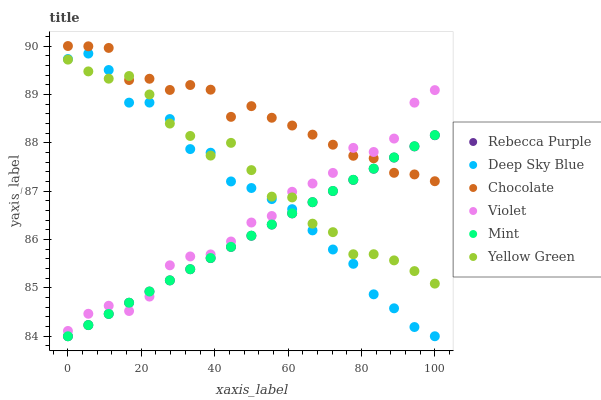Does Rebecca Purple have the minimum area under the curve?
Answer yes or no. Yes. Does Chocolate have the maximum area under the curve?
Answer yes or no. Yes. Does Chocolate have the minimum area under the curve?
Answer yes or no. No. Does Rebecca Purple have the maximum area under the curve?
Answer yes or no. No. Is Mint the smoothest?
Answer yes or no. Yes. Is Violet the roughest?
Answer yes or no. Yes. Is Chocolate the smoothest?
Answer yes or no. No. Is Chocolate the roughest?
Answer yes or no. No. Does Rebecca Purple have the lowest value?
Answer yes or no. Yes. Does Chocolate have the lowest value?
Answer yes or no. No. Does Chocolate have the highest value?
Answer yes or no. Yes. Does Rebecca Purple have the highest value?
Answer yes or no. No. Is Deep Sky Blue less than Chocolate?
Answer yes or no. Yes. Is Chocolate greater than Deep Sky Blue?
Answer yes or no. Yes. Does Violet intersect Mint?
Answer yes or no. Yes. Is Violet less than Mint?
Answer yes or no. No. Is Violet greater than Mint?
Answer yes or no. No. Does Deep Sky Blue intersect Chocolate?
Answer yes or no. No. 